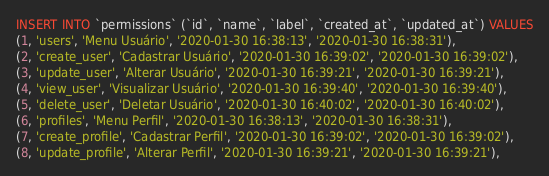<code> <loc_0><loc_0><loc_500><loc_500><_SQL_>INSERT INTO `permissions` (`id`, `name`, `label`, `created_at`, `updated_at`) VALUES
(1, 'users', 'Menu Usuário', '2020-01-30 16:38:13', '2020-01-30 16:38:31'),
(2, 'create_user', 'Cadastrar Usuário', '2020-01-30 16:39:02', '2020-01-30 16:39:02'),
(3, 'update_user', 'Alterar Usuário', '2020-01-30 16:39:21', '2020-01-30 16:39:21'),
(4, 'view_user', 'Visualizar Usuário', '2020-01-30 16:39:40', '2020-01-30 16:39:40'),
(5, 'delete_user', 'Deletar Usuário', '2020-01-30 16:40:02', '2020-01-30 16:40:02'),
(6, 'profiles', 'Menu Perfil', '2020-01-30 16:38:13', '2020-01-30 16:38:31'),
(7, 'create_profile', 'Cadastrar Perfil', '2020-01-30 16:39:02', '2020-01-30 16:39:02'),
(8, 'update_profile', 'Alterar Perfil', '2020-01-30 16:39:21', '2020-01-30 16:39:21'),</code> 